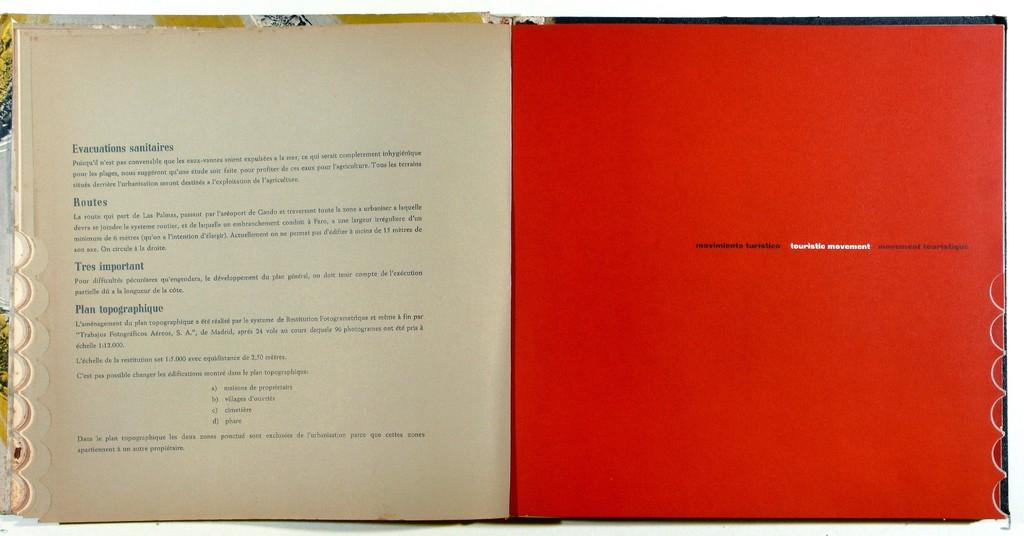Provide a one-sentence caption for the provided image. The words in white on the orange page are touristic movement. 